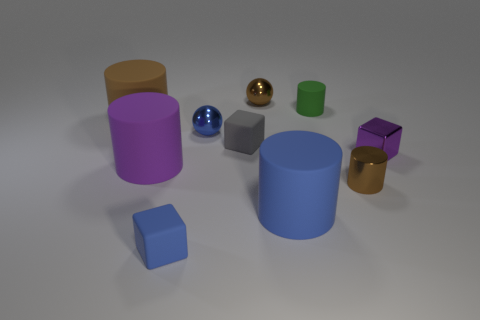How many brown cylinders must be subtracted to get 1 brown cylinders? 1 Subtract all blue cylinders. How many cylinders are left? 4 Subtract all metallic cylinders. How many cylinders are left? 4 Subtract all cyan cylinders. Subtract all gray cubes. How many cylinders are left? 5 Subtract all spheres. How many objects are left? 8 Add 5 small cyan shiny cylinders. How many small cyan shiny cylinders exist? 5 Subtract 0 green balls. How many objects are left? 10 Subtract all tiny cyan shiny cylinders. Subtract all large brown rubber things. How many objects are left? 9 Add 9 brown rubber cylinders. How many brown rubber cylinders are left? 10 